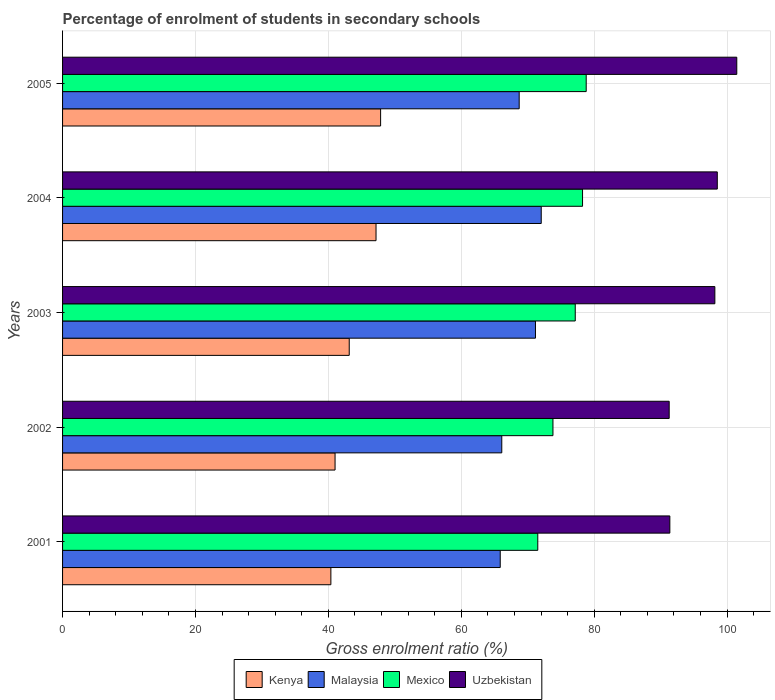How many groups of bars are there?
Provide a succinct answer. 5. Are the number of bars per tick equal to the number of legend labels?
Your answer should be compact. Yes. Are the number of bars on each tick of the Y-axis equal?
Your answer should be very brief. Yes. How many bars are there on the 3rd tick from the bottom?
Offer a very short reply. 4. What is the label of the 2nd group of bars from the top?
Your answer should be compact. 2004. In how many cases, is the number of bars for a given year not equal to the number of legend labels?
Your answer should be very brief. 0. What is the percentage of students enrolled in secondary schools in Malaysia in 2002?
Make the answer very short. 66.1. Across all years, what is the maximum percentage of students enrolled in secondary schools in Malaysia?
Your answer should be very brief. 72.03. Across all years, what is the minimum percentage of students enrolled in secondary schools in Uzbekistan?
Your answer should be very brief. 91.29. What is the total percentage of students enrolled in secondary schools in Mexico in the graph?
Offer a terse response. 379.53. What is the difference between the percentage of students enrolled in secondary schools in Malaysia in 2002 and that in 2003?
Keep it short and to the point. -5.07. What is the difference between the percentage of students enrolled in secondary schools in Malaysia in 2004 and the percentage of students enrolled in secondary schools in Mexico in 2002?
Offer a terse response. -1.77. What is the average percentage of students enrolled in secondary schools in Kenya per year?
Make the answer very short. 43.91. In the year 2002, what is the difference between the percentage of students enrolled in secondary schools in Mexico and percentage of students enrolled in secondary schools in Uzbekistan?
Ensure brevity in your answer.  -17.49. In how many years, is the percentage of students enrolled in secondary schools in Uzbekistan greater than 28 %?
Offer a terse response. 5. What is the ratio of the percentage of students enrolled in secondary schools in Uzbekistan in 2003 to that in 2005?
Provide a short and direct response. 0.97. Is the percentage of students enrolled in secondary schools in Kenya in 2002 less than that in 2003?
Your response must be concise. Yes. What is the difference between the highest and the second highest percentage of students enrolled in secondary schools in Mexico?
Offer a terse response. 0.55. What is the difference between the highest and the lowest percentage of students enrolled in secondary schools in Kenya?
Provide a succinct answer. 7.49. In how many years, is the percentage of students enrolled in secondary schools in Uzbekistan greater than the average percentage of students enrolled in secondary schools in Uzbekistan taken over all years?
Your response must be concise. 3. Is it the case that in every year, the sum of the percentage of students enrolled in secondary schools in Malaysia and percentage of students enrolled in secondary schools in Uzbekistan is greater than the sum of percentage of students enrolled in secondary schools in Mexico and percentage of students enrolled in secondary schools in Kenya?
Offer a terse response. No. What does the 2nd bar from the top in 2002 represents?
Your response must be concise. Mexico. What does the 4th bar from the bottom in 2004 represents?
Provide a short and direct response. Uzbekistan. How many years are there in the graph?
Your response must be concise. 5. What is the difference between two consecutive major ticks on the X-axis?
Give a very brief answer. 20. What is the title of the graph?
Your answer should be very brief. Percentage of enrolment of students in secondary schools. What is the label or title of the Y-axis?
Make the answer very short. Years. What is the Gross enrolment ratio (%) in Kenya in 2001?
Ensure brevity in your answer.  40.38. What is the Gross enrolment ratio (%) of Malaysia in 2001?
Make the answer very short. 65.87. What is the Gross enrolment ratio (%) of Mexico in 2001?
Keep it short and to the point. 71.51. What is the Gross enrolment ratio (%) of Uzbekistan in 2001?
Give a very brief answer. 91.39. What is the Gross enrolment ratio (%) in Kenya in 2002?
Keep it short and to the point. 41.01. What is the Gross enrolment ratio (%) in Malaysia in 2002?
Your response must be concise. 66.1. What is the Gross enrolment ratio (%) of Mexico in 2002?
Your answer should be compact. 73.8. What is the Gross enrolment ratio (%) in Uzbekistan in 2002?
Provide a short and direct response. 91.29. What is the Gross enrolment ratio (%) in Kenya in 2003?
Your response must be concise. 43.14. What is the Gross enrolment ratio (%) in Malaysia in 2003?
Provide a succinct answer. 71.17. What is the Gross enrolment ratio (%) of Mexico in 2003?
Your response must be concise. 77.16. What is the Gross enrolment ratio (%) of Uzbekistan in 2003?
Provide a short and direct response. 98.16. What is the Gross enrolment ratio (%) in Kenya in 2004?
Your answer should be compact. 47.17. What is the Gross enrolment ratio (%) of Malaysia in 2004?
Ensure brevity in your answer.  72.03. What is the Gross enrolment ratio (%) in Mexico in 2004?
Offer a very short reply. 78.25. What is the Gross enrolment ratio (%) of Uzbekistan in 2004?
Keep it short and to the point. 98.53. What is the Gross enrolment ratio (%) in Kenya in 2005?
Offer a very short reply. 47.86. What is the Gross enrolment ratio (%) in Malaysia in 2005?
Provide a succinct answer. 68.72. What is the Gross enrolment ratio (%) in Mexico in 2005?
Your answer should be very brief. 78.8. What is the Gross enrolment ratio (%) of Uzbekistan in 2005?
Keep it short and to the point. 101.46. Across all years, what is the maximum Gross enrolment ratio (%) of Kenya?
Provide a succinct answer. 47.86. Across all years, what is the maximum Gross enrolment ratio (%) of Malaysia?
Make the answer very short. 72.03. Across all years, what is the maximum Gross enrolment ratio (%) in Mexico?
Ensure brevity in your answer.  78.8. Across all years, what is the maximum Gross enrolment ratio (%) of Uzbekistan?
Make the answer very short. 101.46. Across all years, what is the minimum Gross enrolment ratio (%) in Kenya?
Your answer should be very brief. 40.38. Across all years, what is the minimum Gross enrolment ratio (%) in Malaysia?
Give a very brief answer. 65.87. Across all years, what is the minimum Gross enrolment ratio (%) of Mexico?
Make the answer very short. 71.51. Across all years, what is the minimum Gross enrolment ratio (%) in Uzbekistan?
Offer a terse response. 91.29. What is the total Gross enrolment ratio (%) of Kenya in the graph?
Offer a very short reply. 219.56. What is the total Gross enrolment ratio (%) of Malaysia in the graph?
Make the answer very short. 343.88. What is the total Gross enrolment ratio (%) in Mexico in the graph?
Ensure brevity in your answer.  379.53. What is the total Gross enrolment ratio (%) of Uzbekistan in the graph?
Your answer should be very brief. 480.84. What is the difference between the Gross enrolment ratio (%) in Kenya in 2001 and that in 2002?
Your response must be concise. -0.63. What is the difference between the Gross enrolment ratio (%) in Malaysia in 2001 and that in 2002?
Provide a succinct answer. -0.23. What is the difference between the Gross enrolment ratio (%) in Mexico in 2001 and that in 2002?
Your response must be concise. -2.28. What is the difference between the Gross enrolment ratio (%) in Uzbekistan in 2001 and that in 2002?
Your answer should be very brief. 0.1. What is the difference between the Gross enrolment ratio (%) in Kenya in 2001 and that in 2003?
Your response must be concise. -2.76. What is the difference between the Gross enrolment ratio (%) of Malaysia in 2001 and that in 2003?
Your response must be concise. -5.3. What is the difference between the Gross enrolment ratio (%) of Mexico in 2001 and that in 2003?
Offer a very short reply. -5.64. What is the difference between the Gross enrolment ratio (%) of Uzbekistan in 2001 and that in 2003?
Your response must be concise. -6.77. What is the difference between the Gross enrolment ratio (%) in Kenya in 2001 and that in 2004?
Your answer should be very brief. -6.8. What is the difference between the Gross enrolment ratio (%) of Malaysia in 2001 and that in 2004?
Make the answer very short. -6.17. What is the difference between the Gross enrolment ratio (%) of Mexico in 2001 and that in 2004?
Your answer should be very brief. -6.74. What is the difference between the Gross enrolment ratio (%) in Uzbekistan in 2001 and that in 2004?
Make the answer very short. -7.14. What is the difference between the Gross enrolment ratio (%) of Kenya in 2001 and that in 2005?
Keep it short and to the point. -7.49. What is the difference between the Gross enrolment ratio (%) of Malaysia in 2001 and that in 2005?
Offer a terse response. -2.85. What is the difference between the Gross enrolment ratio (%) in Mexico in 2001 and that in 2005?
Provide a short and direct response. -7.29. What is the difference between the Gross enrolment ratio (%) in Uzbekistan in 2001 and that in 2005?
Your response must be concise. -10.07. What is the difference between the Gross enrolment ratio (%) of Kenya in 2002 and that in 2003?
Ensure brevity in your answer.  -2.13. What is the difference between the Gross enrolment ratio (%) of Malaysia in 2002 and that in 2003?
Make the answer very short. -5.07. What is the difference between the Gross enrolment ratio (%) in Mexico in 2002 and that in 2003?
Your answer should be very brief. -3.36. What is the difference between the Gross enrolment ratio (%) of Uzbekistan in 2002 and that in 2003?
Make the answer very short. -6.87. What is the difference between the Gross enrolment ratio (%) in Kenya in 2002 and that in 2004?
Keep it short and to the point. -6.17. What is the difference between the Gross enrolment ratio (%) of Malaysia in 2002 and that in 2004?
Keep it short and to the point. -5.94. What is the difference between the Gross enrolment ratio (%) of Mexico in 2002 and that in 2004?
Make the answer very short. -4.45. What is the difference between the Gross enrolment ratio (%) in Uzbekistan in 2002 and that in 2004?
Give a very brief answer. -7.24. What is the difference between the Gross enrolment ratio (%) of Kenya in 2002 and that in 2005?
Give a very brief answer. -6.85. What is the difference between the Gross enrolment ratio (%) of Malaysia in 2002 and that in 2005?
Provide a short and direct response. -2.62. What is the difference between the Gross enrolment ratio (%) in Mexico in 2002 and that in 2005?
Provide a succinct answer. -5. What is the difference between the Gross enrolment ratio (%) in Uzbekistan in 2002 and that in 2005?
Your answer should be very brief. -10.17. What is the difference between the Gross enrolment ratio (%) in Kenya in 2003 and that in 2004?
Provide a short and direct response. -4.03. What is the difference between the Gross enrolment ratio (%) of Malaysia in 2003 and that in 2004?
Provide a succinct answer. -0.87. What is the difference between the Gross enrolment ratio (%) of Mexico in 2003 and that in 2004?
Offer a very short reply. -1.1. What is the difference between the Gross enrolment ratio (%) in Uzbekistan in 2003 and that in 2004?
Offer a very short reply. -0.37. What is the difference between the Gross enrolment ratio (%) of Kenya in 2003 and that in 2005?
Make the answer very short. -4.72. What is the difference between the Gross enrolment ratio (%) of Malaysia in 2003 and that in 2005?
Make the answer very short. 2.45. What is the difference between the Gross enrolment ratio (%) of Mexico in 2003 and that in 2005?
Your answer should be compact. -1.65. What is the difference between the Gross enrolment ratio (%) of Uzbekistan in 2003 and that in 2005?
Provide a succinct answer. -3.3. What is the difference between the Gross enrolment ratio (%) of Kenya in 2004 and that in 2005?
Keep it short and to the point. -0.69. What is the difference between the Gross enrolment ratio (%) of Malaysia in 2004 and that in 2005?
Your answer should be very brief. 3.32. What is the difference between the Gross enrolment ratio (%) of Mexico in 2004 and that in 2005?
Make the answer very short. -0.55. What is the difference between the Gross enrolment ratio (%) of Uzbekistan in 2004 and that in 2005?
Provide a short and direct response. -2.93. What is the difference between the Gross enrolment ratio (%) of Kenya in 2001 and the Gross enrolment ratio (%) of Malaysia in 2002?
Ensure brevity in your answer.  -25.72. What is the difference between the Gross enrolment ratio (%) of Kenya in 2001 and the Gross enrolment ratio (%) of Mexico in 2002?
Offer a terse response. -33.42. What is the difference between the Gross enrolment ratio (%) of Kenya in 2001 and the Gross enrolment ratio (%) of Uzbekistan in 2002?
Offer a very short reply. -50.91. What is the difference between the Gross enrolment ratio (%) in Malaysia in 2001 and the Gross enrolment ratio (%) in Mexico in 2002?
Offer a terse response. -7.93. What is the difference between the Gross enrolment ratio (%) of Malaysia in 2001 and the Gross enrolment ratio (%) of Uzbekistan in 2002?
Your response must be concise. -25.43. What is the difference between the Gross enrolment ratio (%) of Mexico in 2001 and the Gross enrolment ratio (%) of Uzbekistan in 2002?
Your answer should be very brief. -19.78. What is the difference between the Gross enrolment ratio (%) of Kenya in 2001 and the Gross enrolment ratio (%) of Malaysia in 2003?
Keep it short and to the point. -30.79. What is the difference between the Gross enrolment ratio (%) in Kenya in 2001 and the Gross enrolment ratio (%) in Mexico in 2003?
Make the answer very short. -36.78. What is the difference between the Gross enrolment ratio (%) of Kenya in 2001 and the Gross enrolment ratio (%) of Uzbekistan in 2003?
Offer a very short reply. -57.79. What is the difference between the Gross enrolment ratio (%) of Malaysia in 2001 and the Gross enrolment ratio (%) of Mexico in 2003?
Make the answer very short. -11.29. What is the difference between the Gross enrolment ratio (%) of Malaysia in 2001 and the Gross enrolment ratio (%) of Uzbekistan in 2003?
Give a very brief answer. -32.3. What is the difference between the Gross enrolment ratio (%) in Mexico in 2001 and the Gross enrolment ratio (%) in Uzbekistan in 2003?
Your answer should be compact. -26.65. What is the difference between the Gross enrolment ratio (%) in Kenya in 2001 and the Gross enrolment ratio (%) in Malaysia in 2004?
Give a very brief answer. -31.66. What is the difference between the Gross enrolment ratio (%) of Kenya in 2001 and the Gross enrolment ratio (%) of Mexico in 2004?
Your answer should be compact. -37.87. What is the difference between the Gross enrolment ratio (%) in Kenya in 2001 and the Gross enrolment ratio (%) in Uzbekistan in 2004?
Ensure brevity in your answer.  -58.15. What is the difference between the Gross enrolment ratio (%) in Malaysia in 2001 and the Gross enrolment ratio (%) in Mexico in 2004?
Your answer should be very brief. -12.39. What is the difference between the Gross enrolment ratio (%) of Malaysia in 2001 and the Gross enrolment ratio (%) of Uzbekistan in 2004?
Your answer should be very brief. -32.67. What is the difference between the Gross enrolment ratio (%) in Mexico in 2001 and the Gross enrolment ratio (%) in Uzbekistan in 2004?
Provide a succinct answer. -27.02. What is the difference between the Gross enrolment ratio (%) of Kenya in 2001 and the Gross enrolment ratio (%) of Malaysia in 2005?
Keep it short and to the point. -28.34. What is the difference between the Gross enrolment ratio (%) in Kenya in 2001 and the Gross enrolment ratio (%) in Mexico in 2005?
Offer a very short reply. -38.43. What is the difference between the Gross enrolment ratio (%) in Kenya in 2001 and the Gross enrolment ratio (%) in Uzbekistan in 2005?
Give a very brief answer. -61.09. What is the difference between the Gross enrolment ratio (%) in Malaysia in 2001 and the Gross enrolment ratio (%) in Mexico in 2005?
Make the answer very short. -12.94. What is the difference between the Gross enrolment ratio (%) in Malaysia in 2001 and the Gross enrolment ratio (%) in Uzbekistan in 2005?
Make the answer very short. -35.6. What is the difference between the Gross enrolment ratio (%) in Mexico in 2001 and the Gross enrolment ratio (%) in Uzbekistan in 2005?
Your answer should be very brief. -29.95. What is the difference between the Gross enrolment ratio (%) in Kenya in 2002 and the Gross enrolment ratio (%) in Malaysia in 2003?
Make the answer very short. -30.16. What is the difference between the Gross enrolment ratio (%) of Kenya in 2002 and the Gross enrolment ratio (%) of Mexico in 2003?
Your answer should be compact. -36.15. What is the difference between the Gross enrolment ratio (%) of Kenya in 2002 and the Gross enrolment ratio (%) of Uzbekistan in 2003?
Your response must be concise. -57.16. What is the difference between the Gross enrolment ratio (%) of Malaysia in 2002 and the Gross enrolment ratio (%) of Mexico in 2003?
Your answer should be very brief. -11.06. What is the difference between the Gross enrolment ratio (%) in Malaysia in 2002 and the Gross enrolment ratio (%) in Uzbekistan in 2003?
Offer a terse response. -32.07. What is the difference between the Gross enrolment ratio (%) in Mexico in 2002 and the Gross enrolment ratio (%) in Uzbekistan in 2003?
Your response must be concise. -24.36. What is the difference between the Gross enrolment ratio (%) of Kenya in 2002 and the Gross enrolment ratio (%) of Malaysia in 2004?
Keep it short and to the point. -31.03. What is the difference between the Gross enrolment ratio (%) of Kenya in 2002 and the Gross enrolment ratio (%) of Mexico in 2004?
Give a very brief answer. -37.24. What is the difference between the Gross enrolment ratio (%) of Kenya in 2002 and the Gross enrolment ratio (%) of Uzbekistan in 2004?
Your answer should be very brief. -57.52. What is the difference between the Gross enrolment ratio (%) of Malaysia in 2002 and the Gross enrolment ratio (%) of Mexico in 2004?
Offer a terse response. -12.15. What is the difference between the Gross enrolment ratio (%) of Malaysia in 2002 and the Gross enrolment ratio (%) of Uzbekistan in 2004?
Offer a very short reply. -32.43. What is the difference between the Gross enrolment ratio (%) of Mexico in 2002 and the Gross enrolment ratio (%) of Uzbekistan in 2004?
Offer a very short reply. -24.73. What is the difference between the Gross enrolment ratio (%) of Kenya in 2002 and the Gross enrolment ratio (%) of Malaysia in 2005?
Keep it short and to the point. -27.71. What is the difference between the Gross enrolment ratio (%) in Kenya in 2002 and the Gross enrolment ratio (%) in Mexico in 2005?
Offer a very short reply. -37.8. What is the difference between the Gross enrolment ratio (%) of Kenya in 2002 and the Gross enrolment ratio (%) of Uzbekistan in 2005?
Provide a short and direct response. -60.45. What is the difference between the Gross enrolment ratio (%) in Malaysia in 2002 and the Gross enrolment ratio (%) in Mexico in 2005?
Give a very brief answer. -12.71. What is the difference between the Gross enrolment ratio (%) of Malaysia in 2002 and the Gross enrolment ratio (%) of Uzbekistan in 2005?
Keep it short and to the point. -35.37. What is the difference between the Gross enrolment ratio (%) in Mexico in 2002 and the Gross enrolment ratio (%) in Uzbekistan in 2005?
Make the answer very short. -27.66. What is the difference between the Gross enrolment ratio (%) in Kenya in 2003 and the Gross enrolment ratio (%) in Malaysia in 2004?
Provide a short and direct response. -28.89. What is the difference between the Gross enrolment ratio (%) in Kenya in 2003 and the Gross enrolment ratio (%) in Mexico in 2004?
Give a very brief answer. -35.11. What is the difference between the Gross enrolment ratio (%) in Kenya in 2003 and the Gross enrolment ratio (%) in Uzbekistan in 2004?
Give a very brief answer. -55.39. What is the difference between the Gross enrolment ratio (%) of Malaysia in 2003 and the Gross enrolment ratio (%) of Mexico in 2004?
Make the answer very short. -7.08. What is the difference between the Gross enrolment ratio (%) in Malaysia in 2003 and the Gross enrolment ratio (%) in Uzbekistan in 2004?
Give a very brief answer. -27.36. What is the difference between the Gross enrolment ratio (%) in Mexico in 2003 and the Gross enrolment ratio (%) in Uzbekistan in 2004?
Your response must be concise. -21.38. What is the difference between the Gross enrolment ratio (%) of Kenya in 2003 and the Gross enrolment ratio (%) of Malaysia in 2005?
Your answer should be very brief. -25.58. What is the difference between the Gross enrolment ratio (%) of Kenya in 2003 and the Gross enrolment ratio (%) of Mexico in 2005?
Your answer should be compact. -35.66. What is the difference between the Gross enrolment ratio (%) in Kenya in 2003 and the Gross enrolment ratio (%) in Uzbekistan in 2005?
Make the answer very short. -58.32. What is the difference between the Gross enrolment ratio (%) in Malaysia in 2003 and the Gross enrolment ratio (%) in Mexico in 2005?
Make the answer very short. -7.64. What is the difference between the Gross enrolment ratio (%) in Malaysia in 2003 and the Gross enrolment ratio (%) in Uzbekistan in 2005?
Make the answer very short. -30.3. What is the difference between the Gross enrolment ratio (%) of Mexico in 2003 and the Gross enrolment ratio (%) of Uzbekistan in 2005?
Give a very brief answer. -24.31. What is the difference between the Gross enrolment ratio (%) in Kenya in 2004 and the Gross enrolment ratio (%) in Malaysia in 2005?
Offer a terse response. -21.54. What is the difference between the Gross enrolment ratio (%) in Kenya in 2004 and the Gross enrolment ratio (%) in Mexico in 2005?
Provide a succinct answer. -31.63. What is the difference between the Gross enrolment ratio (%) in Kenya in 2004 and the Gross enrolment ratio (%) in Uzbekistan in 2005?
Your response must be concise. -54.29. What is the difference between the Gross enrolment ratio (%) in Malaysia in 2004 and the Gross enrolment ratio (%) in Mexico in 2005?
Your answer should be very brief. -6.77. What is the difference between the Gross enrolment ratio (%) in Malaysia in 2004 and the Gross enrolment ratio (%) in Uzbekistan in 2005?
Your response must be concise. -29.43. What is the difference between the Gross enrolment ratio (%) in Mexico in 2004 and the Gross enrolment ratio (%) in Uzbekistan in 2005?
Your answer should be compact. -23.21. What is the average Gross enrolment ratio (%) of Kenya per year?
Provide a succinct answer. 43.91. What is the average Gross enrolment ratio (%) in Malaysia per year?
Give a very brief answer. 68.78. What is the average Gross enrolment ratio (%) of Mexico per year?
Make the answer very short. 75.91. What is the average Gross enrolment ratio (%) in Uzbekistan per year?
Offer a terse response. 96.17. In the year 2001, what is the difference between the Gross enrolment ratio (%) of Kenya and Gross enrolment ratio (%) of Malaysia?
Provide a short and direct response. -25.49. In the year 2001, what is the difference between the Gross enrolment ratio (%) in Kenya and Gross enrolment ratio (%) in Mexico?
Make the answer very short. -31.14. In the year 2001, what is the difference between the Gross enrolment ratio (%) of Kenya and Gross enrolment ratio (%) of Uzbekistan?
Make the answer very short. -51.01. In the year 2001, what is the difference between the Gross enrolment ratio (%) of Malaysia and Gross enrolment ratio (%) of Mexico?
Offer a terse response. -5.65. In the year 2001, what is the difference between the Gross enrolment ratio (%) in Malaysia and Gross enrolment ratio (%) in Uzbekistan?
Your answer should be very brief. -25.52. In the year 2001, what is the difference between the Gross enrolment ratio (%) of Mexico and Gross enrolment ratio (%) of Uzbekistan?
Provide a short and direct response. -19.88. In the year 2002, what is the difference between the Gross enrolment ratio (%) in Kenya and Gross enrolment ratio (%) in Malaysia?
Make the answer very short. -25.09. In the year 2002, what is the difference between the Gross enrolment ratio (%) of Kenya and Gross enrolment ratio (%) of Mexico?
Your response must be concise. -32.79. In the year 2002, what is the difference between the Gross enrolment ratio (%) in Kenya and Gross enrolment ratio (%) in Uzbekistan?
Ensure brevity in your answer.  -50.28. In the year 2002, what is the difference between the Gross enrolment ratio (%) of Malaysia and Gross enrolment ratio (%) of Mexico?
Offer a very short reply. -7.7. In the year 2002, what is the difference between the Gross enrolment ratio (%) in Malaysia and Gross enrolment ratio (%) in Uzbekistan?
Provide a succinct answer. -25.19. In the year 2002, what is the difference between the Gross enrolment ratio (%) of Mexico and Gross enrolment ratio (%) of Uzbekistan?
Your answer should be very brief. -17.49. In the year 2003, what is the difference between the Gross enrolment ratio (%) of Kenya and Gross enrolment ratio (%) of Malaysia?
Ensure brevity in your answer.  -28.03. In the year 2003, what is the difference between the Gross enrolment ratio (%) of Kenya and Gross enrolment ratio (%) of Mexico?
Make the answer very short. -34.02. In the year 2003, what is the difference between the Gross enrolment ratio (%) in Kenya and Gross enrolment ratio (%) in Uzbekistan?
Your response must be concise. -55.02. In the year 2003, what is the difference between the Gross enrolment ratio (%) in Malaysia and Gross enrolment ratio (%) in Mexico?
Keep it short and to the point. -5.99. In the year 2003, what is the difference between the Gross enrolment ratio (%) of Malaysia and Gross enrolment ratio (%) of Uzbekistan?
Give a very brief answer. -27. In the year 2003, what is the difference between the Gross enrolment ratio (%) in Mexico and Gross enrolment ratio (%) in Uzbekistan?
Ensure brevity in your answer.  -21.01. In the year 2004, what is the difference between the Gross enrolment ratio (%) of Kenya and Gross enrolment ratio (%) of Malaysia?
Your response must be concise. -24.86. In the year 2004, what is the difference between the Gross enrolment ratio (%) in Kenya and Gross enrolment ratio (%) in Mexico?
Give a very brief answer. -31.08. In the year 2004, what is the difference between the Gross enrolment ratio (%) of Kenya and Gross enrolment ratio (%) of Uzbekistan?
Make the answer very short. -51.36. In the year 2004, what is the difference between the Gross enrolment ratio (%) in Malaysia and Gross enrolment ratio (%) in Mexico?
Your answer should be compact. -6.22. In the year 2004, what is the difference between the Gross enrolment ratio (%) in Malaysia and Gross enrolment ratio (%) in Uzbekistan?
Ensure brevity in your answer.  -26.5. In the year 2004, what is the difference between the Gross enrolment ratio (%) of Mexico and Gross enrolment ratio (%) of Uzbekistan?
Your answer should be very brief. -20.28. In the year 2005, what is the difference between the Gross enrolment ratio (%) of Kenya and Gross enrolment ratio (%) of Malaysia?
Offer a terse response. -20.85. In the year 2005, what is the difference between the Gross enrolment ratio (%) of Kenya and Gross enrolment ratio (%) of Mexico?
Your answer should be very brief. -30.94. In the year 2005, what is the difference between the Gross enrolment ratio (%) in Kenya and Gross enrolment ratio (%) in Uzbekistan?
Provide a succinct answer. -53.6. In the year 2005, what is the difference between the Gross enrolment ratio (%) in Malaysia and Gross enrolment ratio (%) in Mexico?
Keep it short and to the point. -10.09. In the year 2005, what is the difference between the Gross enrolment ratio (%) of Malaysia and Gross enrolment ratio (%) of Uzbekistan?
Your answer should be compact. -32.75. In the year 2005, what is the difference between the Gross enrolment ratio (%) in Mexico and Gross enrolment ratio (%) in Uzbekistan?
Give a very brief answer. -22.66. What is the ratio of the Gross enrolment ratio (%) in Kenya in 2001 to that in 2002?
Provide a short and direct response. 0.98. What is the ratio of the Gross enrolment ratio (%) in Malaysia in 2001 to that in 2002?
Keep it short and to the point. 1. What is the ratio of the Gross enrolment ratio (%) in Kenya in 2001 to that in 2003?
Provide a succinct answer. 0.94. What is the ratio of the Gross enrolment ratio (%) of Malaysia in 2001 to that in 2003?
Give a very brief answer. 0.93. What is the ratio of the Gross enrolment ratio (%) in Mexico in 2001 to that in 2003?
Your answer should be compact. 0.93. What is the ratio of the Gross enrolment ratio (%) of Uzbekistan in 2001 to that in 2003?
Offer a very short reply. 0.93. What is the ratio of the Gross enrolment ratio (%) of Kenya in 2001 to that in 2004?
Offer a very short reply. 0.86. What is the ratio of the Gross enrolment ratio (%) in Malaysia in 2001 to that in 2004?
Offer a very short reply. 0.91. What is the ratio of the Gross enrolment ratio (%) in Mexico in 2001 to that in 2004?
Your response must be concise. 0.91. What is the ratio of the Gross enrolment ratio (%) in Uzbekistan in 2001 to that in 2004?
Ensure brevity in your answer.  0.93. What is the ratio of the Gross enrolment ratio (%) of Kenya in 2001 to that in 2005?
Provide a succinct answer. 0.84. What is the ratio of the Gross enrolment ratio (%) in Malaysia in 2001 to that in 2005?
Your answer should be very brief. 0.96. What is the ratio of the Gross enrolment ratio (%) of Mexico in 2001 to that in 2005?
Offer a terse response. 0.91. What is the ratio of the Gross enrolment ratio (%) of Uzbekistan in 2001 to that in 2005?
Ensure brevity in your answer.  0.9. What is the ratio of the Gross enrolment ratio (%) of Kenya in 2002 to that in 2003?
Keep it short and to the point. 0.95. What is the ratio of the Gross enrolment ratio (%) of Malaysia in 2002 to that in 2003?
Give a very brief answer. 0.93. What is the ratio of the Gross enrolment ratio (%) in Mexico in 2002 to that in 2003?
Your answer should be compact. 0.96. What is the ratio of the Gross enrolment ratio (%) of Kenya in 2002 to that in 2004?
Make the answer very short. 0.87. What is the ratio of the Gross enrolment ratio (%) of Malaysia in 2002 to that in 2004?
Give a very brief answer. 0.92. What is the ratio of the Gross enrolment ratio (%) of Mexico in 2002 to that in 2004?
Make the answer very short. 0.94. What is the ratio of the Gross enrolment ratio (%) of Uzbekistan in 2002 to that in 2004?
Make the answer very short. 0.93. What is the ratio of the Gross enrolment ratio (%) in Kenya in 2002 to that in 2005?
Your answer should be very brief. 0.86. What is the ratio of the Gross enrolment ratio (%) of Malaysia in 2002 to that in 2005?
Give a very brief answer. 0.96. What is the ratio of the Gross enrolment ratio (%) in Mexico in 2002 to that in 2005?
Offer a very short reply. 0.94. What is the ratio of the Gross enrolment ratio (%) in Uzbekistan in 2002 to that in 2005?
Keep it short and to the point. 0.9. What is the ratio of the Gross enrolment ratio (%) of Kenya in 2003 to that in 2004?
Your answer should be compact. 0.91. What is the ratio of the Gross enrolment ratio (%) of Malaysia in 2003 to that in 2004?
Your response must be concise. 0.99. What is the ratio of the Gross enrolment ratio (%) of Uzbekistan in 2003 to that in 2004?
Provide a succinct answer. 1. What is the ratio of the Gross enrolment ratio (%) of Kenya in 2003 to that in 2005?
Your response must be concise. 0.9. What is the ratio of the Gross enrolment ratio (%) of Malaysia in 2003 to that in 2005?
Offer a very short reply. 1.04. What is the ratio of the Gross enrolment ratio (%) of Mexico in 2003 to that in 2005?
Offer a terse response. 0.98. What is the ratio of the Gross enrolment ratio (%) of Uzbekistan in 2003 to that in 2005?
Your response must be concise. 0.97. What is the ratio of the Gross enrolment ratio (%) in Kenya in 2004 to that in 2005?
Offer a terse response. 0.99. What is the ratio of the Gross enrolment ratio (%) of Malaysia in 2004 to that in 2005?
Provide a short and direct response. 1.05. What is the ratio of the Gross enrolment ratio (%) of Mexico in 2004 to that in 2005?
Your answer should be compact. 0.99. What is the ratio of the Gross enrolment ratio (%) in Uzbekistan in 2004 to that in 2005?
Your answer should be very brief. 0.97. What is the difference between the highest and the second highest Gross enrolment ratio (%) in Kenya?
Your response must be concise. 0.69. What is the difference between the highest and the second highest Gross enrolment ratio (%) of Malaysia?
Offer a terse response. 0.87. What is the difference between the highest and the second highest Gross enrolment ratio (%) of Mexico?
Give a very brief answer. 0.55. What is the difference between the highest and the second highest Gross enrolment ratio (%) of Uzbekistan?
Ensure brevity in your answer.  2.93. What is the difference between the highest and the lowest Gross enrolment ratio (%) of Kenya?
Offer a very short reply. 7.49. What is the difference between the highest and the lowest Gross enrolment ratio (%) of Malaysia?
Your answer should be very brief. 6.17. What is the difference between the highest and the lowest Gross enrolment ratio (%) in Mexico?
Make the answer very short. 7.29. What is the difference between the highest and the lowest Gross enrolment ratio (%) in Uzbekistan?
Provide a succinct answer. 10.17. 